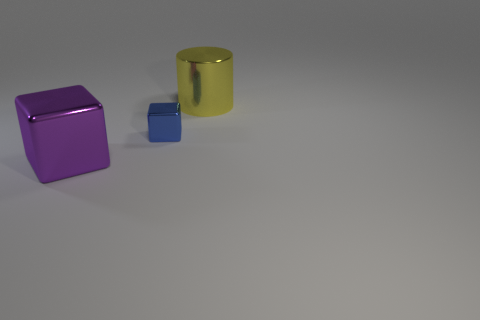Can you describe the lighting and shadows in the scene? Certainly. The lighting in the scene comes from the upper left, casting soft-edged shadows to the lower right of the objects. This creates a natural and slightly diffused look, suggesting an indoor setting with possibly indirect natural light or soft artificial light. The shadows help to give depth and dimension to the objects, enhancing their three-dimensional appearance. 